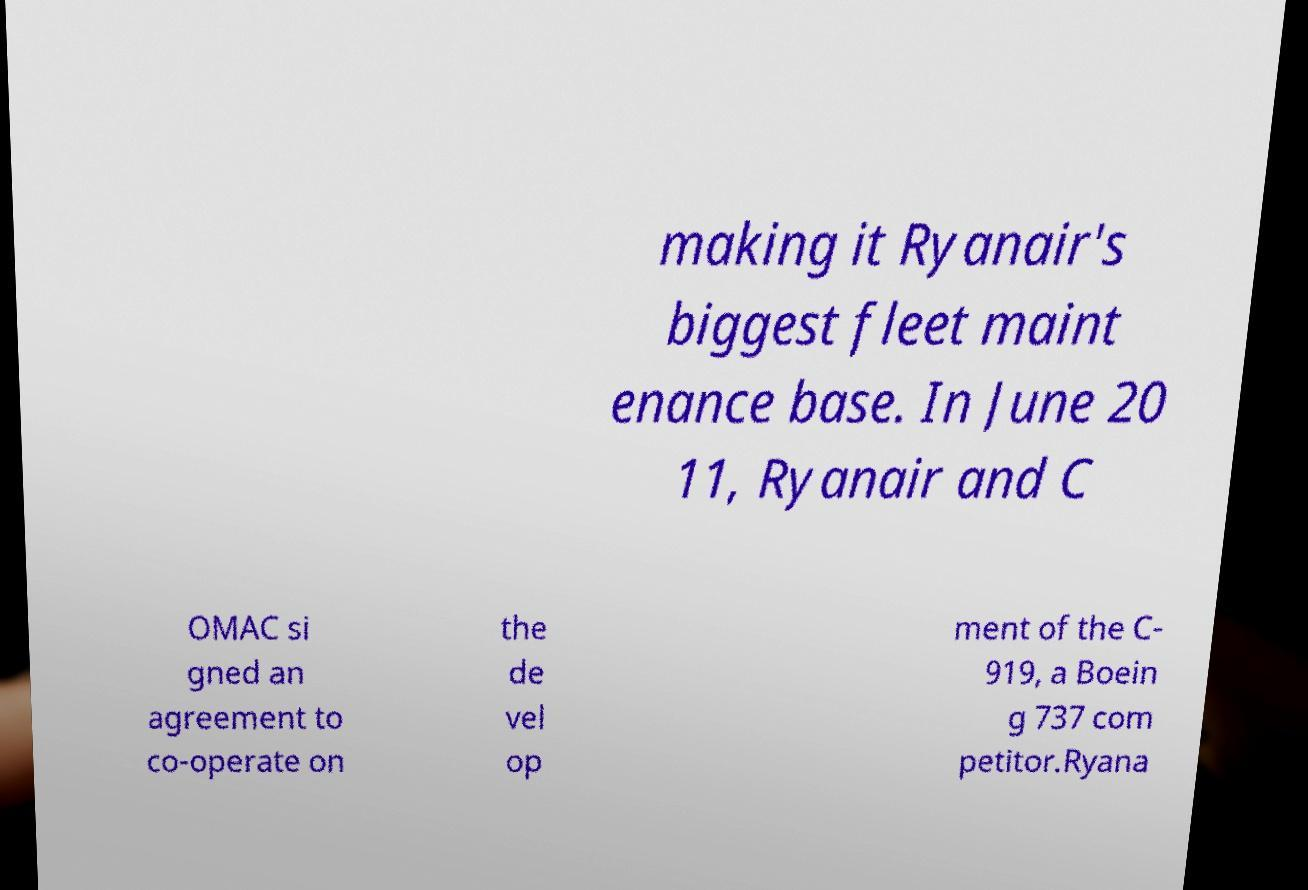Could you assist in decoding the text presented in this image and type it out clearly? making it Ryanair's biggest fleet maint enance base. In June 20 11, Ryanair and C OMAC si gned an agreement to co-operate on the de vel op ment of the C- 919, a Boein g 737 com petitor.Ryana 